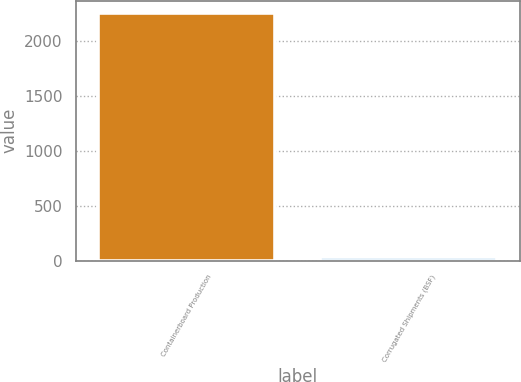Convert chart. <chart><loc_0><loc_0><loc_500><loc_500><bar_chart><fcel>Containerboard Production<fcel>Corrugated Shipments (BSF)<nl><fcel>2258<fcel>28.9<nl></chart> 